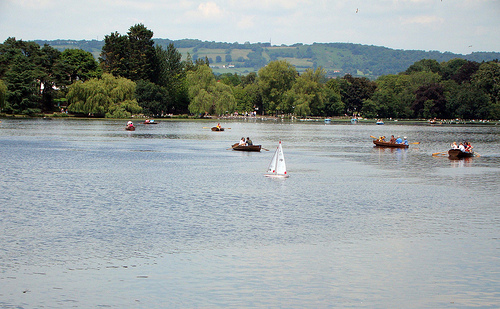<image>
Is the boat behind the water? No. The boat is not behind the water. From this viewpoint, the boat appears to be positioned elsewhere in the scene. 